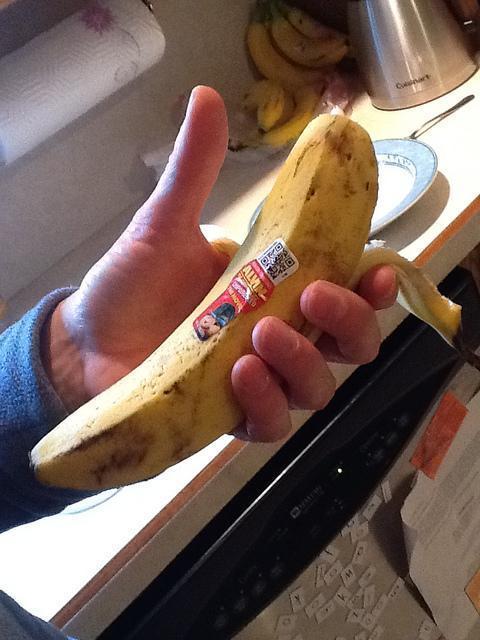How many bananas is the person holding?
Give a very brief answer. 1. How many bananas are there?
Give a very brief answer. 3. How many people are holding book in their hand ?
Give a very brief answer. 0. 